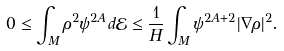<formula> <loc_0><loc_0><loc_500><loc_500>0 \leq \int _ { M } \rho ^ { 2 } \psi ^ { 2 A } d \mathcal { E } \leq \frac { 1 } { H } \int _ { M } \psi ^ { 2 A + 2 } | \nabla \rho | ^ { 2 } .</formula> 